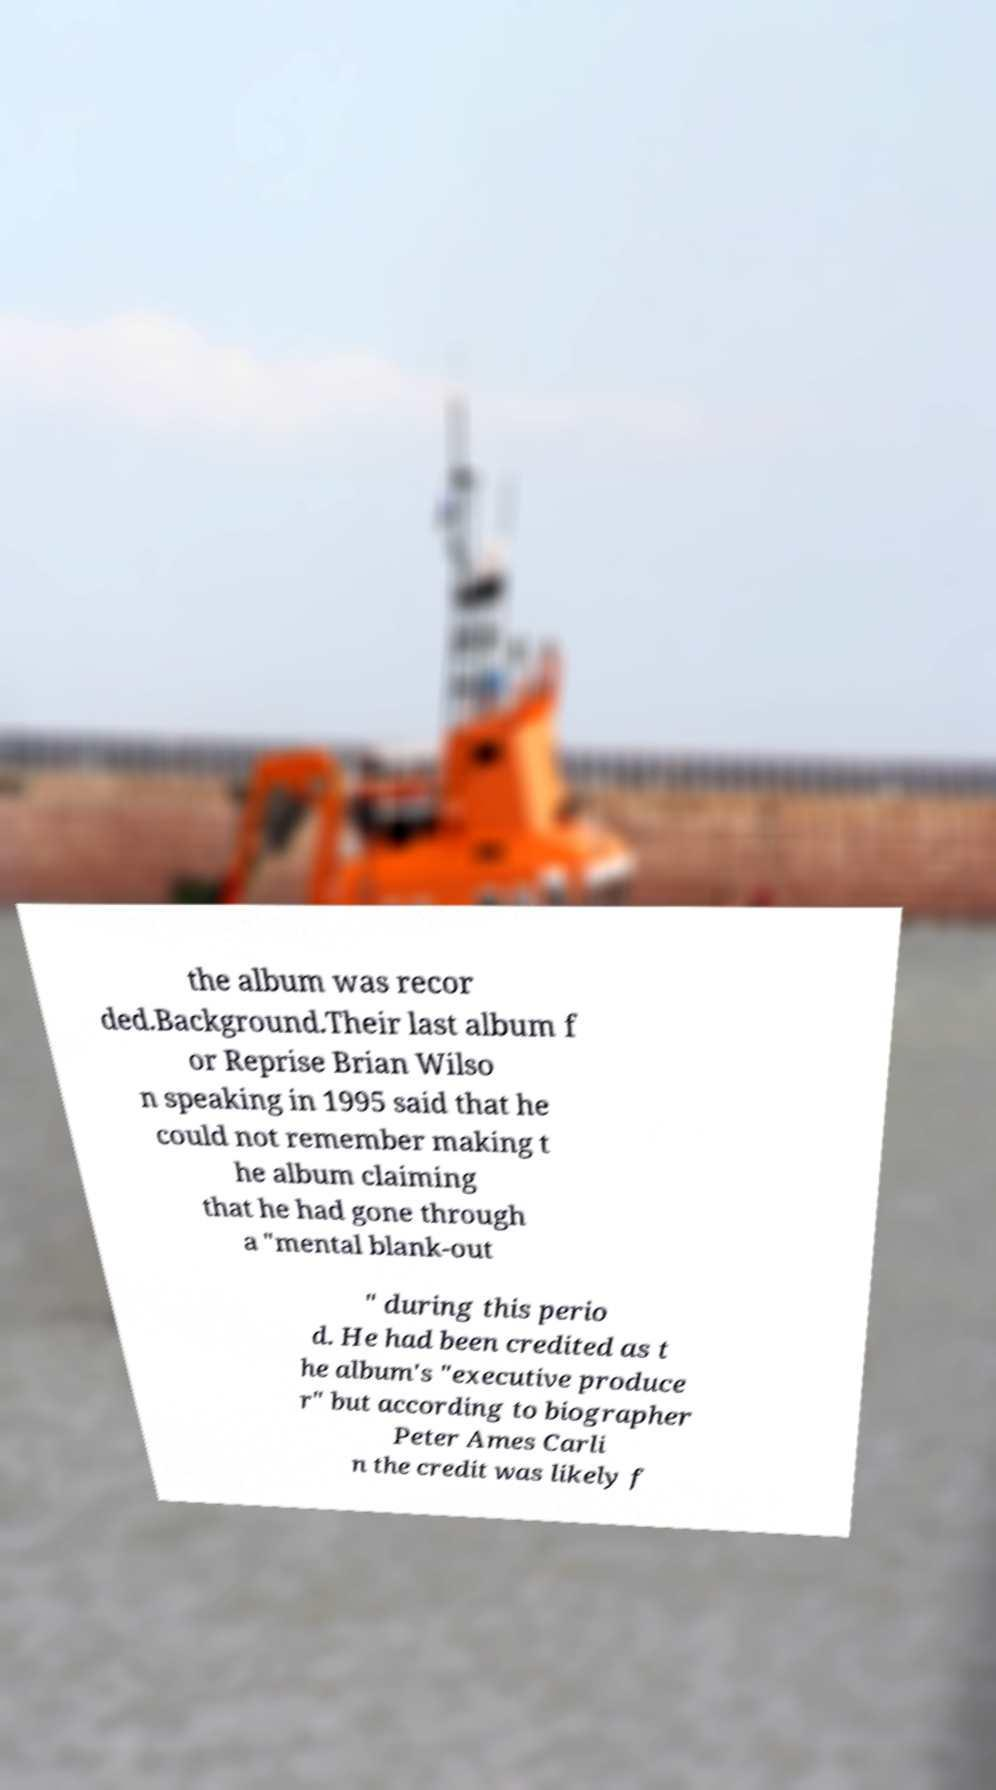Can you accurately transcribe the text from the provided image for me? the album was recor ded.Background.Their last album f or Reprise Brian Wilso n speaking in 1995 said that he could not remember making t he album claiming that he had gone through a "mental blank-out " during this perio d. He had been credited as t he album's "executive produce r" but according to biographer Peter Ames Carli n the credit was likely f 